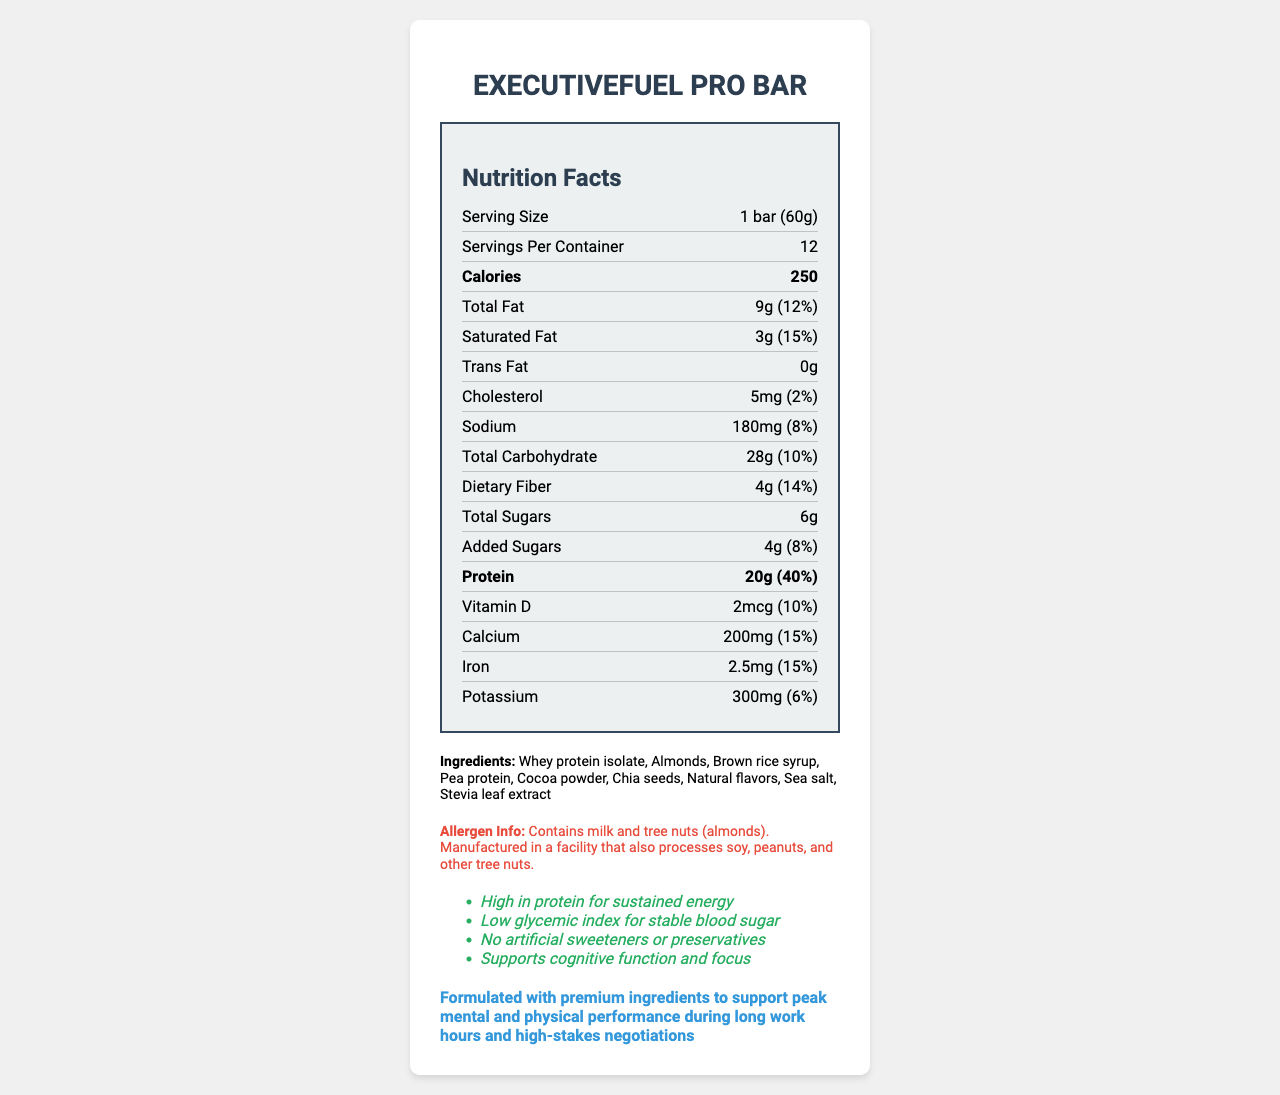what is the serving size of ExecutiveFuel Pro Bar? The serving size is stated directly in the nutrition label as "1 bar (60g)".
Answer: 1 bar (60g) how many calories are in one serving of the ExecutiveFuel Pro Bar? The calorie content per serving is clearly listed in the nutrition label as "250".
Answer: 250 what percentage of daily value does the protein content of the ExecutiveFuel Pro Bar provide? The daily value percentage for protein content is listed in the nutrition label as "40%".
Answer: 40% list the allergens mentioned in the ExecutiveFuel Pro Bar's allergen information. The allergen information explicitly states that the product contains milk and tree nuts (almonds).
Answer: Milk and tree nuts (almonds). how much total carbohydrate does one serving of ExecutiveFuel Pro Bar contain? The total carbohydrate content per serving is shown as "28g" in the nutrition label.
Answer: 28g what are the main benefits highlighted in the marketing claims? These benefits are clearly listed under the marketing claims section of the document.
Answer: High in protein for sustained energy, Low glycemic index for stable blood sugar, No artificial sweeteners or preservatives, Supports cognitive function and focus which ingredient is listed first in the ExecutiveFuel Pro Bar's ingredients list? A. Almonds B. Whey protein isolate C. Brown rice syrup The first ingredient listed is "Whey protein isolate", indicating it is the primary ingredient.
Answer: B. Whey protein isolate how much sodium is in one bar of ExecutiveFuel Pro Bar? A. 100mg B. 150mg C. 180mg D. 200mg The nutrition label lists the sodium content as "180mg".
Answer: C. 180mg is the ExecutiveFuel Pro Bar free from trans fat? The nutrition label states that the trans fat content is "0g", indicating it is free from trans fat.
Answer: Yes describe the primary target audience and competitive edge of the ExecutiveFuel Pro Bar. The document specifies that the target audience is busy executives and high-performing professionals. The competitive edge is highlighted as the bar being formulated with premium ingredients to support mental and physical performance.
Answer: Busy executives and high-performing professionals; Formulated with premium ingredients to support peak mental and physical performance during long work hours and high-stakes negotiations what is the manufacturing facility cross-contact information for the ExecutiveFuel Pro Bar? The allergen information notes that the bar contains milk and tree nuts and is manufactured in a facility that processes soy, peanuts, and other tree nuts.
Answer: Contains milk and tree nuts (almonds). Manufactured in a facility that also processes soy, peanuts, and other tree nuts. how many grams of dietary fiber are in one serving? The nutrition label lists the dietary fiber content as "4g".
Answer: 4g can you determine the company that manufactures ExecutiveFuel Pro Bar? The document does not provide any details about the manufacturing company.
Answer: Not enough information how does the ExecutiveFuel Pro Bar support cognitive function? The claim is made in the marketing section, but no additional information on how this support is achieved is provided.
Answer: The marketing claims state that it supports cognitive function and focus, but specific ingredients or mechanisms are not detailed. 